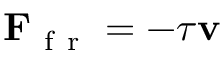Convert formula to latex. <formula><loc_0><loc_0><loc_500><loc_500>F _ { f r } = - \tau v</formula> 